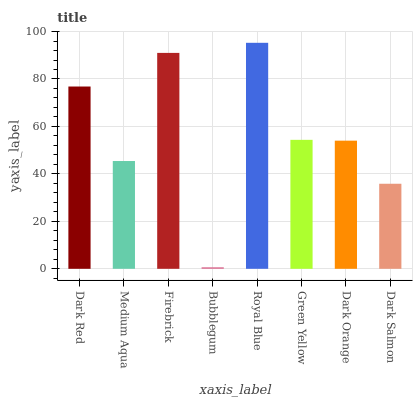Is Bubblegum the minimum?
Answer yes or no. Yes. Is Royal Blue the maximum?
Answer yes or no. Yes. Is Medium Aqua the minimum?
Answer yes or no. No. Is Medium Aqua the maximum?
Answer yes or no. No. Is Dark Red greater than Medium Aqua?
Answer yes or no. Yes. Is Medium Aqua less than Dark Red?
Answer yes or no. Yes. Is Medium Aqua greater than Dark Red?
Answer yes or no. No. Is Dark Red less than Medium Aqua?
Answer yes or no. No. Is Green Yellow the high median?
Answer yes or no. Yes. Is Dark Orange the low median?
Answer yes or no. Yes. Is Royal Blue the high median?
Answer yes or no. No. Is Firebrick the low median?
Answer yes or no. No. 